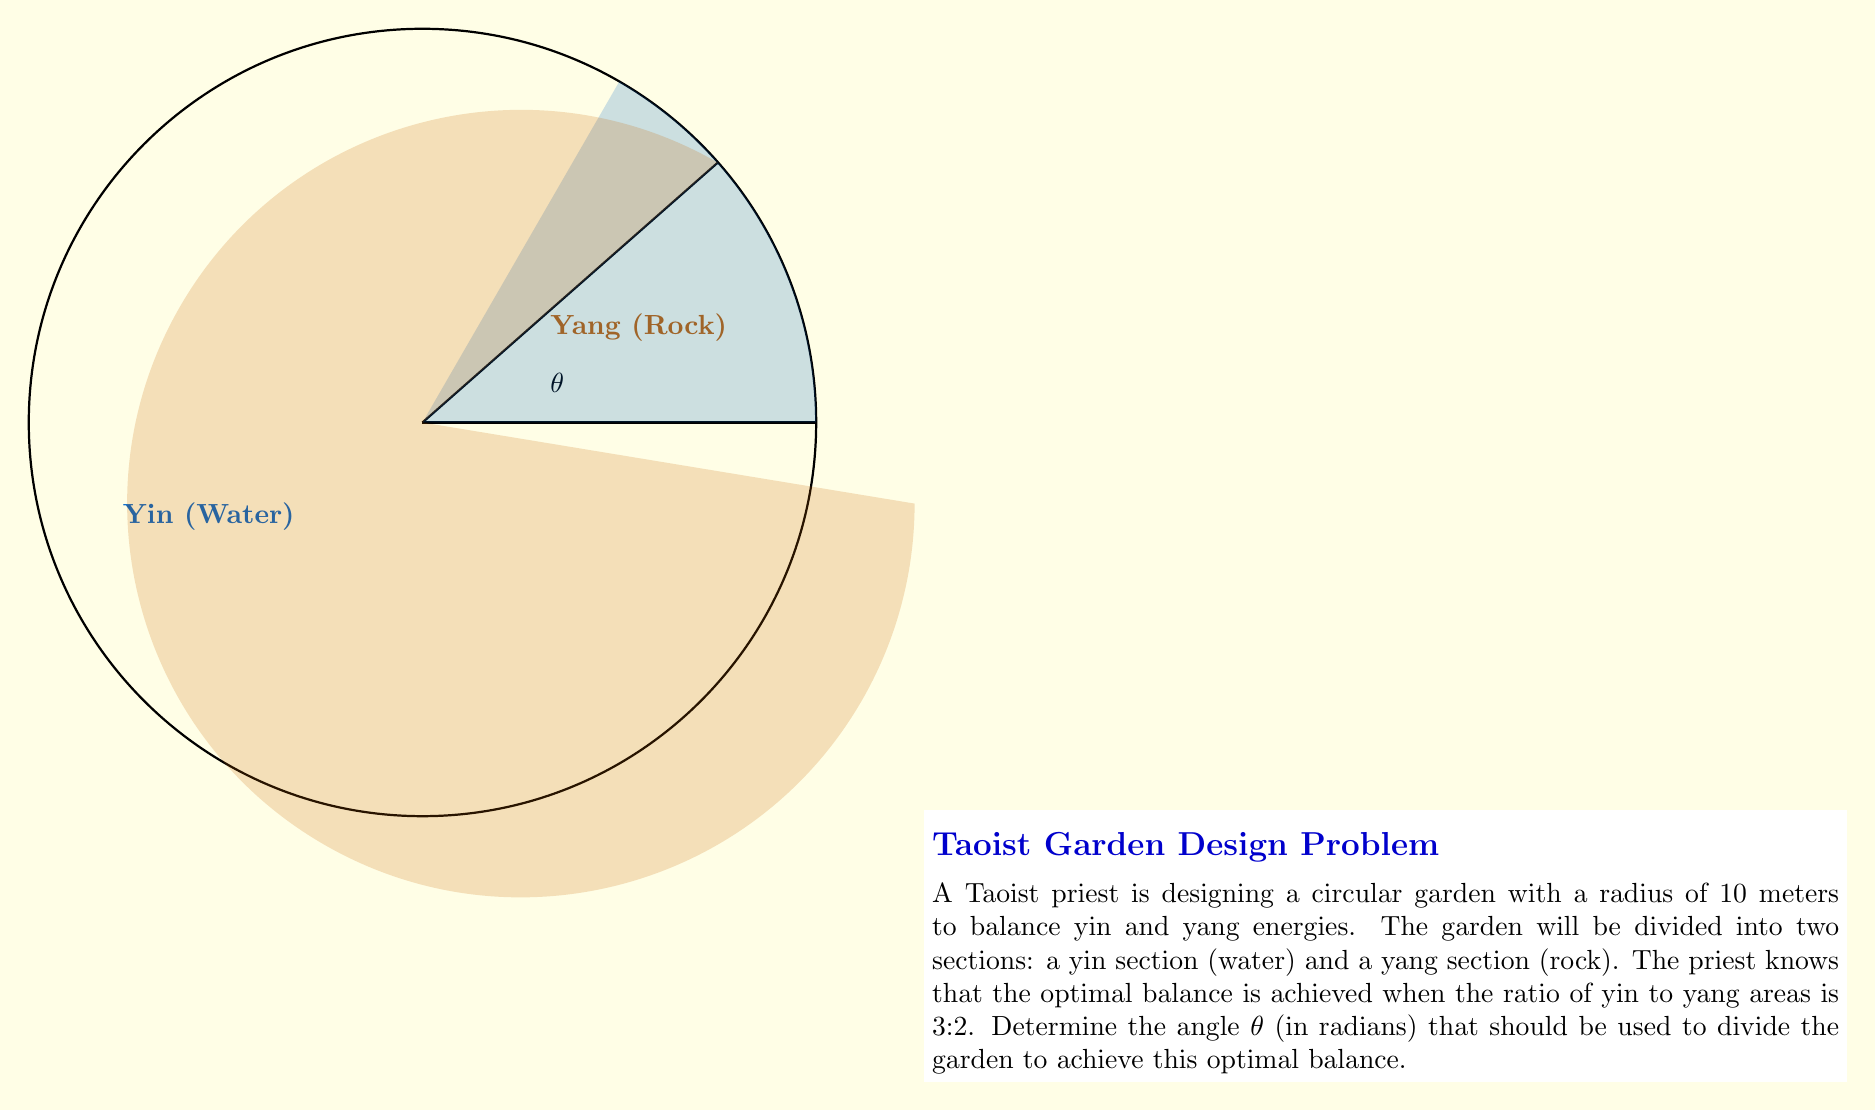Teach me how to tackle this problem. Let's approach this step-by-step:

1) The total area of the circular garden is:
   $$A_{total} = \pi r^2 = \pi (10)^2 = 100\pi \text{ m}^2$$

2) Let the angle θ represent the portion of the circle allocated to the yin section. The area of this section is given by:
   $$A_{yin} = \frac{\theta}{2\pi} \cdot 100\pi = 50\theta \text{ m}^2$$

3) The remaining area is the yang section:
   $$A_{yang} = 100\pi - 50\theta \text{ m}^2$$

4) We want the ratio of yin to yang areas to be 3:2. This can be expressed as:
   $$\frac{A_{yin}}{A_{yang}} = \frac{3}{2}$$

5) Substituting our area expressions:
   $$\frac{50\theta}{100\pi - 50\theta} = \frac{3}{2}$$

6) Cross-multiply:
   $$2(50\theta) = 3(100\pi - 50\theta)$$
   $$100\theta = 300\pi - 150\theta$$

7) Solve for θ:
   $$250\theta = 300\pi$$
   $$\theta = \frac{300\pi}{250} = \frac{6\pi}{5} = 3.77 \text{ radians}$$

8) Verify:
   Yin area: $50 \cdot \frac{6\pi}{5} = 60\pi \text{ m}^2$
   Yang area: $100\pi - 60\pi = 40\pi \text{ m}^2$
   Ratio: $\frac{60\pi}{40\pi} = \frac{3}{2}$

Therefore, the angle θ should be $\frac{6\pi}{5}$ radians to achieve the optimal 3:2 ratio of yin to yang areas.
Answer: $\frac{6\pi}{5}$ radians 